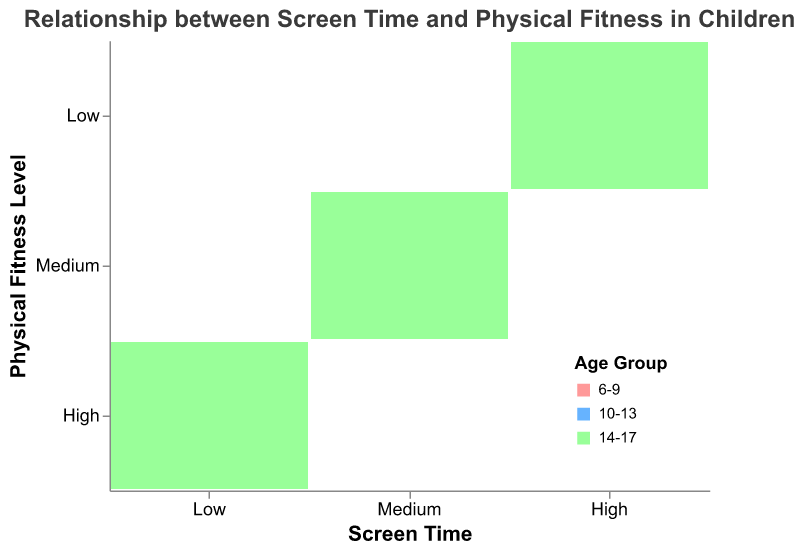What is the title of the chart? The title is usually located at the top of the chart and describes what the chart is about. In this case, it should be clear from the text.
Answer: Relationship between Screen Time and Physical Fitness in Children How is the physical fitness level represented in the chart? The physical fitness level is represented by the y-axis. Different fitness levels (High, Medium, Low) are sorted vertically.
Answer: Y-axis What age groups are included in the data? The age groups are indicated by the color legend. By looking at the colors, we can determine the different age groups represented in the chart. The legend lists them explicitly.
Answer: 6-9, 10-13, 14-17 Which screen time category is associated with the highest physical fitness level? The screen time categories are represented on the x-axis, and the physical fitness level is on the y-axis. By looking at the intersections, we can identify which screen time category falls into the highest physical fitness level.
Answer: Low Which age group has the most data points with high physical fitness and low screen time? We need to identify the rectangles that represent "High" physical fitness and "Low" screen time, then look at the colors to determine which age group appears most frequently.
Answer: All three age groups equally How does screen time affect physical fitness levels according to the observed data? To answer this, we look at the pattern of data across all combinations of screen time and physical fitness levels. Notice that higher screen time tends to correlate with lower fitness levels.
Answer: Higher screen time correlates with lower fitness levels Are there any instances where children with high screen time have high physical fitness levels? By looking at the high screen time segment on the x-axis and trying to find rectangles that represent high physical fitness levels on the y-axis, we observe there are none.
Answer: No Which age group has the most balanced distribution of screen time and physical fitness levels? A balanced distribution would mean roughly equal representation across all categories. By examining the sizes and distribution of rectangles for each age group color, we can determine this.
Answer: 6-9 What can be inferred about the gender distribution in this dataset? Since gender distinctions are not represented by color or any other visual cue, we understand that gender distribution is balanced across categories.
Answer: Balanced In which age group and screen time category is the medium physical fitness level most prevalent? To answer this, identify the rectangles that correspond to "Medium" fitness level and examine the colors and screen time categories of these rectangles.
Answer: Age group 6-9, with medium screen time 